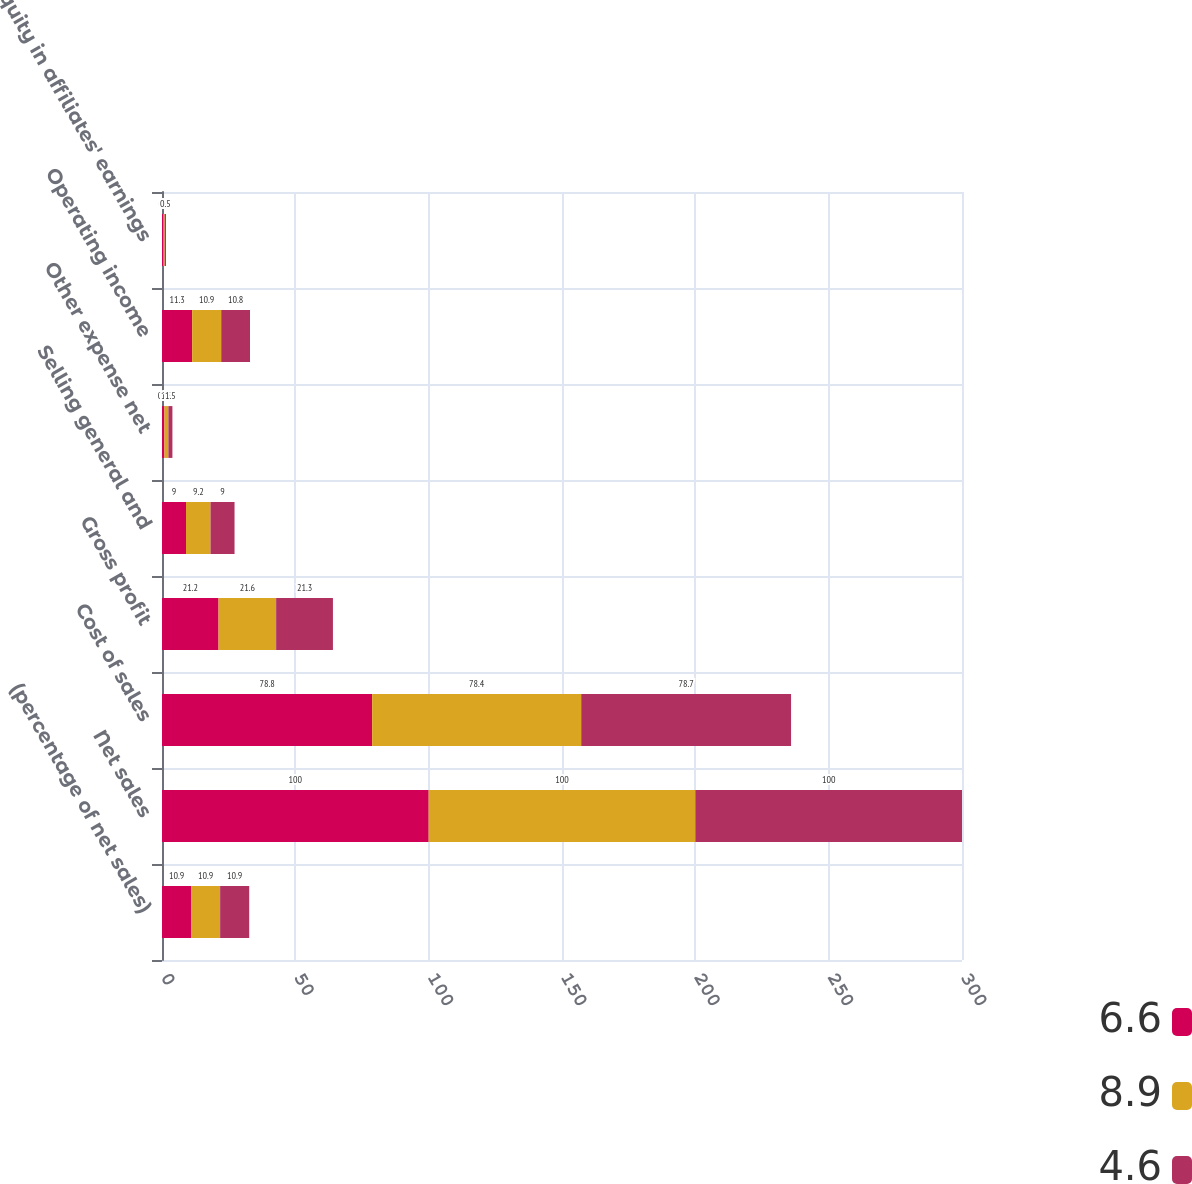Convert chart. <chart><loc_0><loc_0><loc_500><loc_500><stacked_bar_chart><ecel><fcel>(percentage of net sales)<fcel>Net sales<fcel>Cost of sales<fcel>Gross profit<fcel>Selling general and<fcel>Other expense net<fcel>Operating income<fcel>Equity in affiliates' earnings<nl><fcel>6.6<fcel>10.9<fcel>100<fcel>78.8<fcel>21.2<fcel>9<fcel>0.9<fcel>11.3<fcel>0.5<nl><fcel>8.9<fcel>10.9<fcel>100<fcel>78.4<fcel>21.6<fcel>9.2<fcel>1.5<fcel>10.9<fcel>0.5<nl><fcel>4.6<fcel>10.9<fcel>100<fcel>78.7<fcel>21.3<fcel>9<fcel>1.5<fcel>10.8<fcel>0.5<nl></chart> 